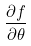Convert formula to latex. <formula><loc_0><loc_0><loc_500><loc_500>\frac { \partial f } { \partial \theta }</formula> 